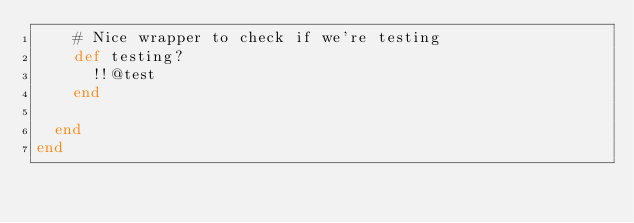<code> <loc_0><loc_0><loc_500><loc_500><_Ruby_>    # Nice wrapper to check if we're testing
    def testing?
      !!@test
    end

  end
end
</code> 